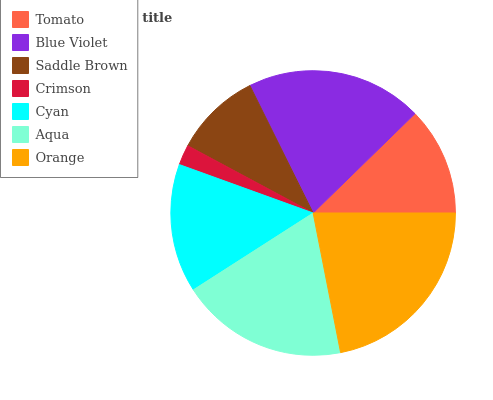Is Crimson the minimum?
Answer yes or no. Yes. Is Orange the maximum?
Answer yes or no. Yes. Is Blue Violet the minimum?
Answer yes or no. No. Is Blue Violet the maximum?
Answer yes or no. No. Is Blue Violet greater than Tomato?
Answer yes or no. Yes. Is Tomato less than Blue Violet?
Answer yes or no. Yes. Is Tomato greater than Blue Violet?
Answer yes or no. No. Is Blue Violet less than Tomato?
Answer yes or no. No. Is Cyan the high median?
Answer yes or no. Yes. Is Cyan the low median?
Answer yes or no. Yes. Is Crimson the high median?
Answer yes or no. No. Is Blue Violet the low median?
Answer yes or no. No. 